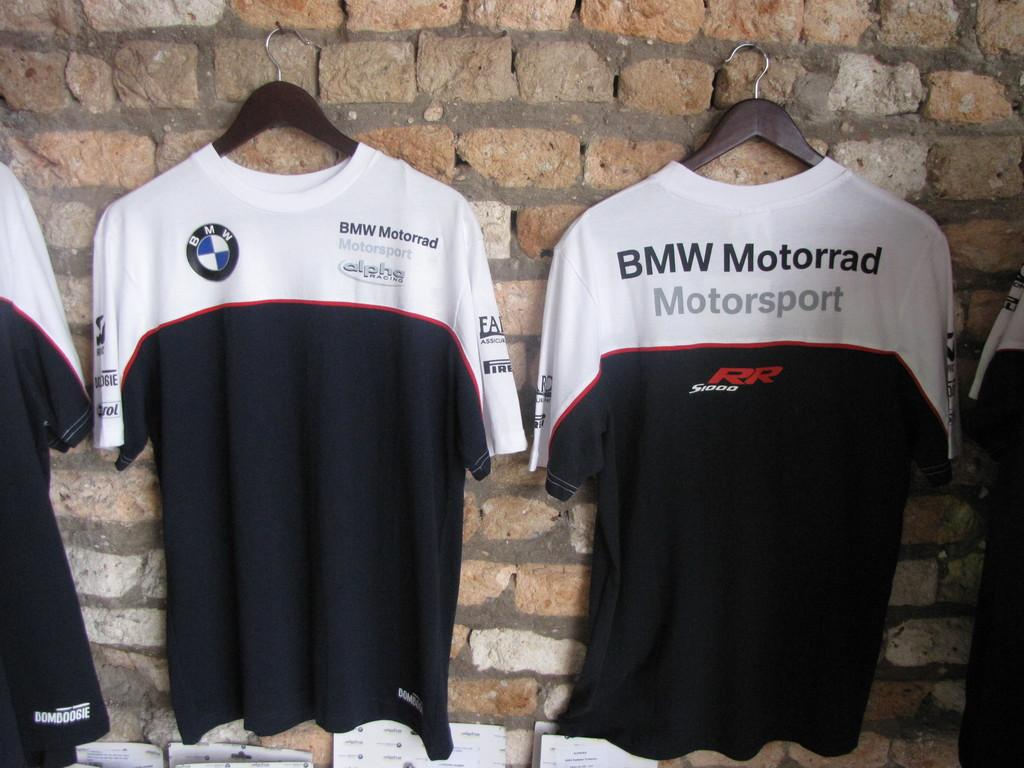<image>
Create a compact narrative representing the image presented. two soccer jerseys hanging on a wall for team BMW Motarrad 